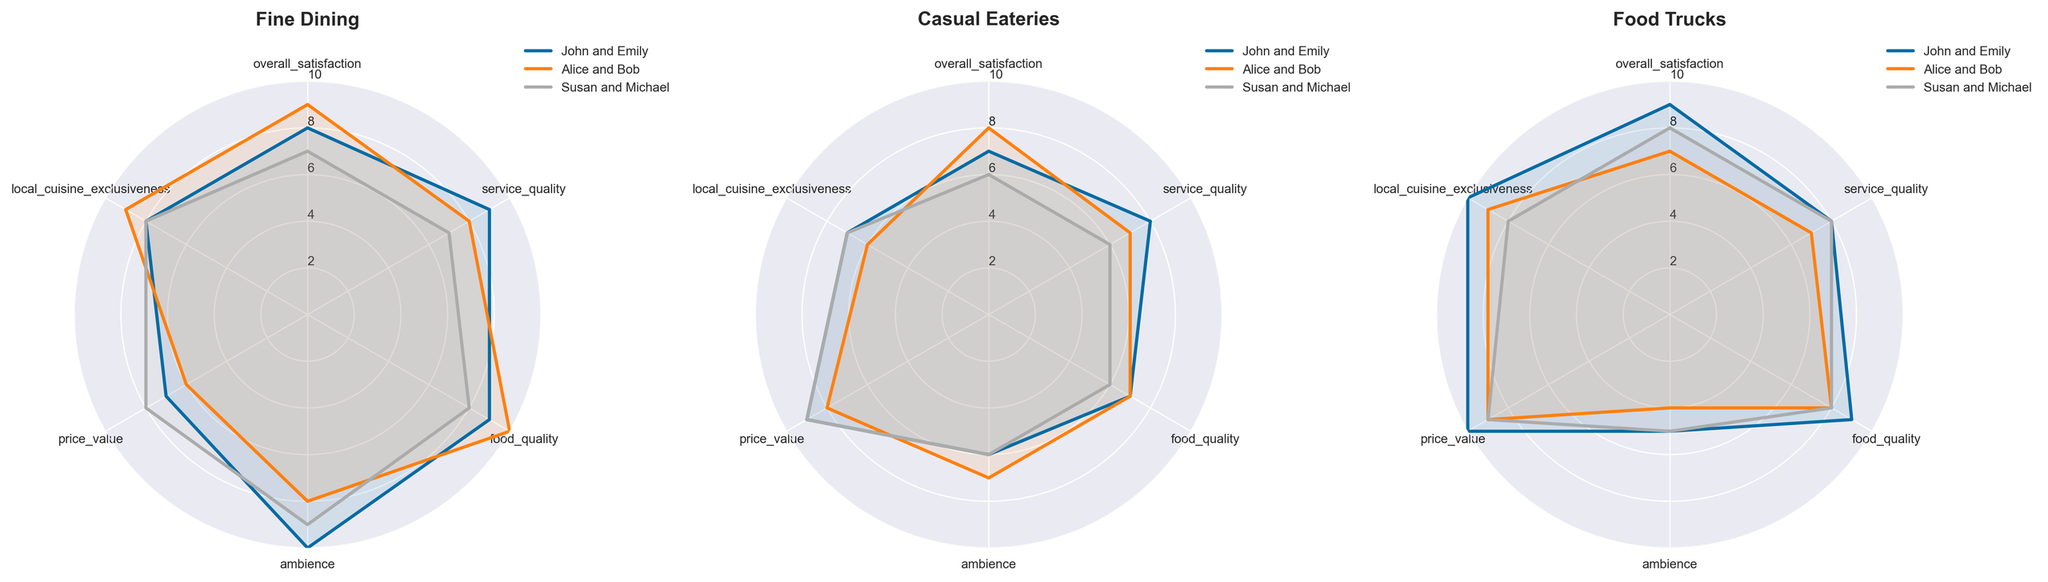What are the categories represented in the radar charts? The radar charts include the following categories: overall satisfaction, service quality, food quality, ambience, price value, and local cuisine exclusiveness. These are visible as the labels on the outer circle of each radar chart.
Answer: Overall satisfaction, service quality, food quality, ambience, price value, local cuisine exclusiveness How many tourists' preferences are plotted for each dining type? Each radar chart represents the preferences of three sets of tourists: John and Emily, Alice and Bob, and Susan and Michael. This can be seen by the three different lines plotted on each chart, each labeled accordingly in the legend.
Answer: Three Which dining type has the highest average score for overall satisfaction? Fine Dining appears to have the highest average score for overall satisfaction. We need to compare the overall satisfaction category for each tourist group across the radar charts. Fine Dining values are 8, 9, and 7, leading to an average of (8+9+7)/3 = 8. Casual Eateries have 7, 8, and 6, averaging (7+8+6)/3 = 7. And Food Trucks have 9, 7, and 8, averaging (9+7+8)/3 = 8. Fine Dining is tied with Food Trucks.
Answer: Fine Dining and Food Trucks Which tourist group values price value the most in Food Trucks? In the Food Trucks radar chart, John and Emily have the highest score for price value at 10, visible as the outermost point on the price value category for that chart.
Answer: John and Emily What is the difference in ambience satisfaction between Alice and Bob in Fine Dining and Casual Eateries? For Fine Dining, Alice and Bob rated ambience as 8. For Casual Eateries, they rated ambience as 7. The difference is 8 - 7 = 1.
Answer: 1 Which tourist group has the lowest score for service quality across all dining types? Susan and Michael have the lowest scores in service quality for Casual Eateries with a score of 6, easily visible as the smallest radiating value in the Casual Eateries service quality category.
Answer: Susan and Michael Compare the exclusiveness of local cuisine ratings for John and Emily in all dining experiences. John and Emily rated local cuisine exclusiveness as 8 for Fine Dining, 7 for Casual Eateries, and 10 for Food Trucks. The highest rating is for Food Trucks (10), followed by Fine Dining (8), and Casual Eateries (7).
Answer: Food Trucks > Fine Dining > Casual Eateries How consistent are Susan and Michael's ratings across all dining types for food quality? Susan and Michael rated food quality as follows: Fine Dining (8), Casual Eateries (6), Food Trucks (8). They have the same ratings for Fine Dining and Food Trucks, but a lower rating for Casual Eateries, indicating variability.
Answer: Inconsistent Which category has the largest variation in scores for Fine Dining? For Fine Dining, the categories and their scores are: overall satisfaction (7-9), service quality (7-9), food quality (8-10), ambience (8-10), price value (6-8), and local cuisine exclusiveness (8-9). The largest variation is in service quality and food quality, both varying by 2 points.
Answer: Service quality and food quality 